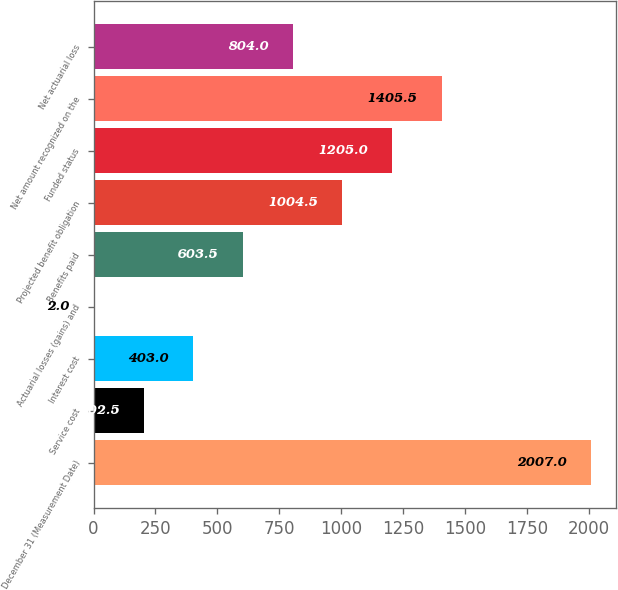Convert chart to OTSL. <chart><loc_0><loc_0><loc_500><loc_500><bar_chart><fcel>December 31 (Measurement Date)<fcel>Service cost<fcel>Interest cost<fcel>Actuarial losses (gains) and<fcel>Benefits paid<fcel>Projected benefit obligation<fcel>Funded status<fcel>Net amount recognized on the<fcel>Net actuarial loss<nl><fcel>2007<fcel>202.5<fcel>403<fcel>2<fcel>603.5<fcel>1004.5<fcel>1205<fcel>1405.5<fcel>804<nl></chart> 